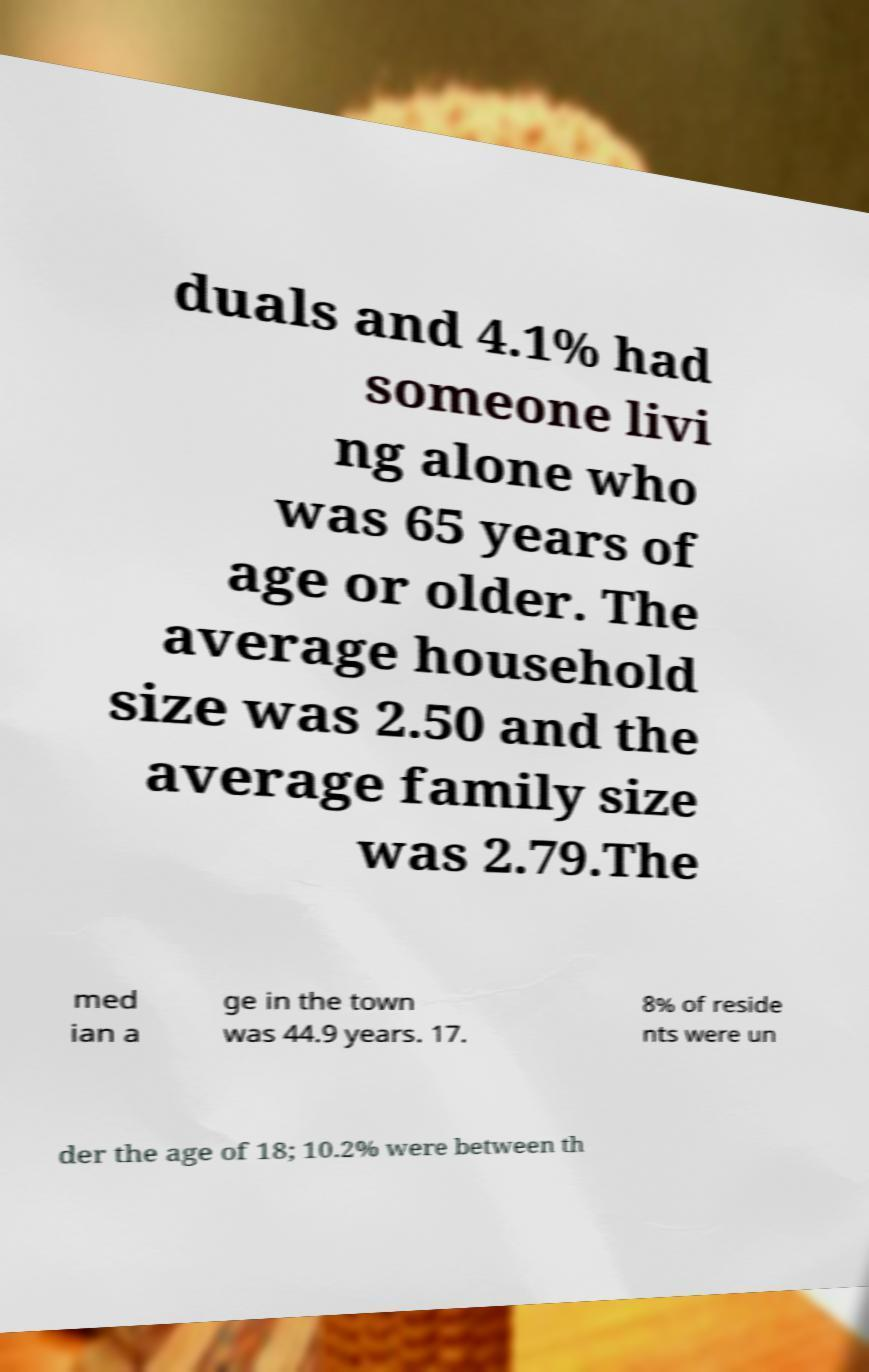What messages or text are displayed in this image? I need them in a readable, typed format. duals and 4.1% had someone livi ng alone who was 65 years of age or older. The average household size was 2.50 and the average family size was 2.79.The med ian a ge in the town was 44.9 years. 17. 8% of reside nts were un der the age of 18; 10.2% were between th 